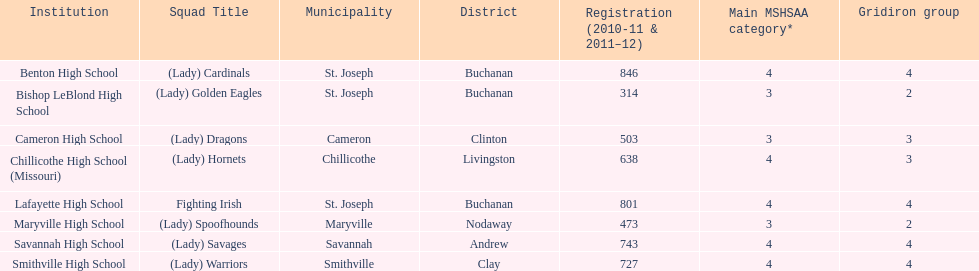How many teams are named after birds? 2. 